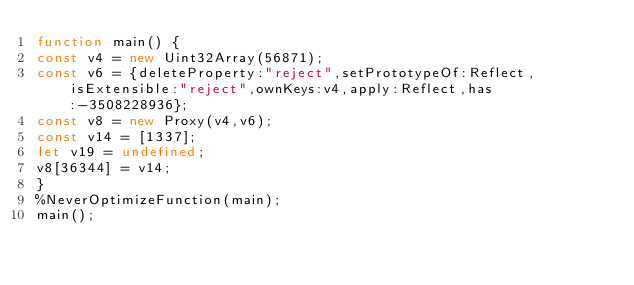<code> <loc_0><loc_0><loc_500><loc_500><_JavaScript_>function main() {
const v4 = new Uint32Array(56871);
const v6 = {deleteProperty:"reject",setPrototypeOf:Reflect,isExtensible:"reject",ownKeys:v4,apply:Reflect,has:-3508228936};
const v8 = new Proxy(v4,v6);
const v14 = [1337];
let v19 = undefined;
v8[36344] = v14;
}
%NeverOptimizeFunction(main);
main();
</code> 